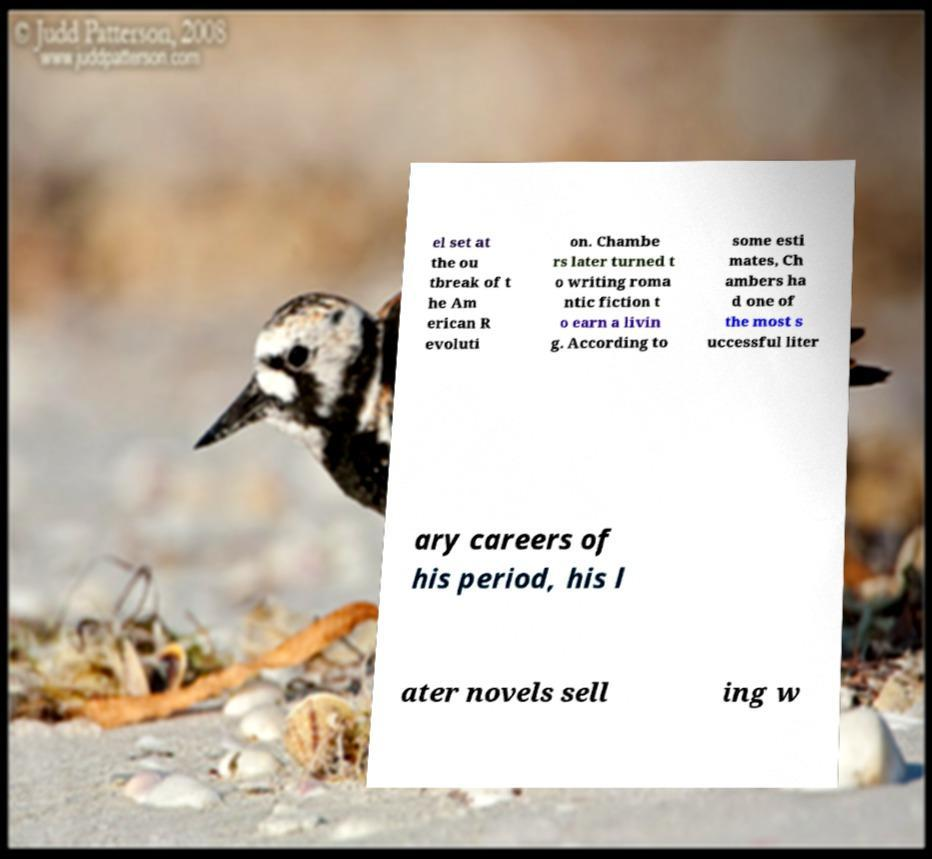For documentation purposes, I need the text within this image transcribed. Could you provide that? el set at the ou tbreak of t he Am erican R evoluti on. Chambe rs later turned t o writing roma ntic fiction t o earn a livin g. According to some esti mates, Ch ambers ha d one of the most s uccessful liter ary careers of his period, his l ater novels sell ing w 